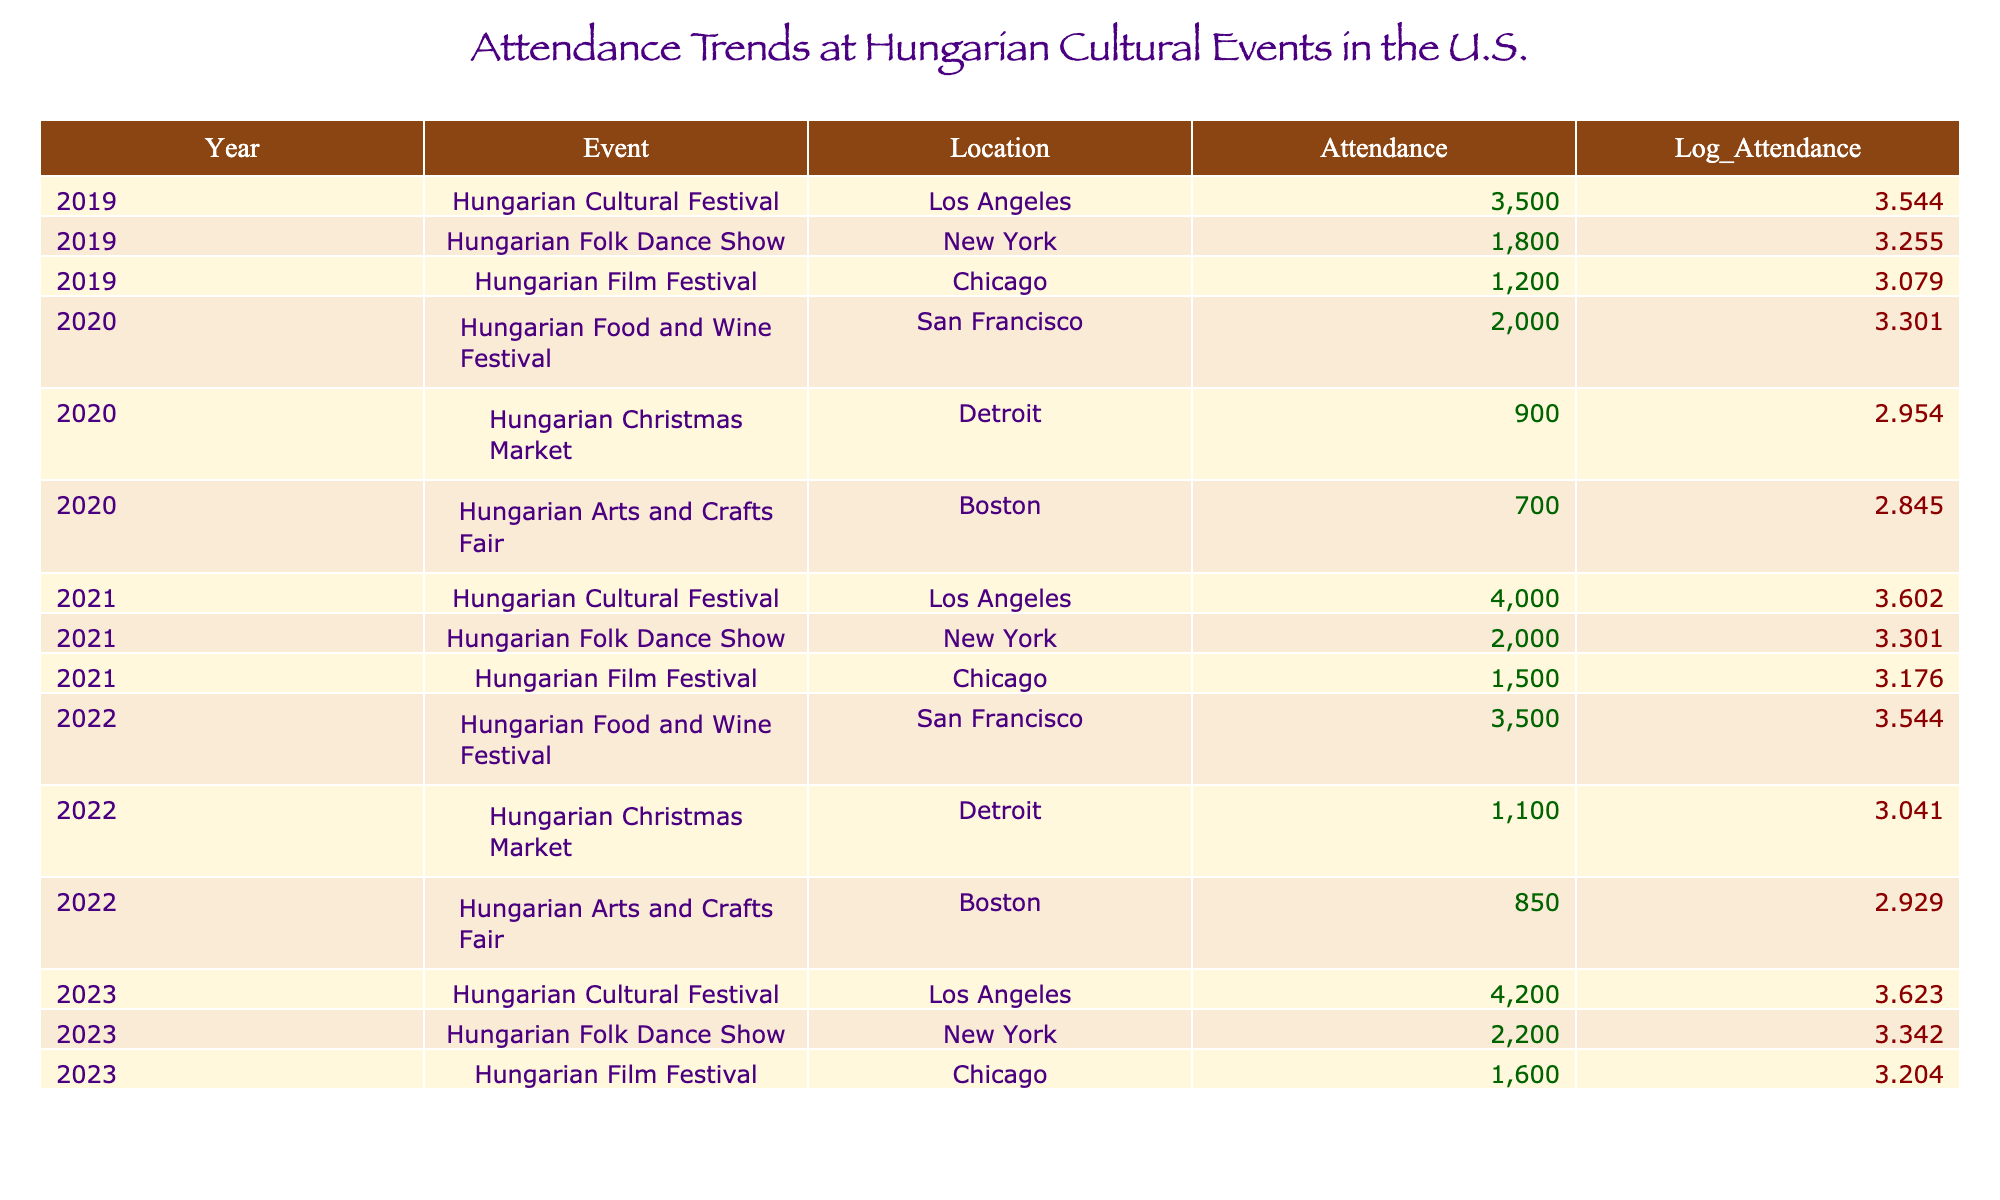What was the attendance at the Hungarian Folk Dance Show in 2021? The table shows that the attendance at the Hungarian Folk Dance Show in 2021 was 2000.
Answer: 2000 Which event had the highest attendance in 2023? According to the table, the Hungarian Cultural Festival in Los Angeles had the highest attendance in 2023, with 4200 participants.
Answer: 4200 What is the total attendance across all events in 2020? The attendance for each event in 2020 is 2000 (Food and Wine Festival) + 900 (Christmas Market) + 700 (Arts and Crafts Fair) = 3600.
Answer: 3600 Did attendance at the Hungarian Film Festival increase from 2019 to 2023? In 2019, the attendance was 1200 and in 2023 it was 1600. Since 1600 is greater than 1200, it indicates an increase.
Answer: Yes What was the trend in attendance from 2019 to 2023 for the Hungarian Cultural Festival? The attendance figures for the Hungarian Cultural Festival are: 3500 in 2019, 4000 in 2021, and 4200 in 2023. This shows a steady increase in attendance over these years.
Answer: Increasing What was the average attendance for the Hungarian Arts and Crafts Fair over the five years? The attendance figures for the Hungarian Arts and Crafts Fair are: 700 (2020), 850 (2022), and no data for 2019, 2021, and 2023. Thus, the average is (700 + 850) / 2 = 775.
Answer: 775 Was 2022 the year with the lowest attendance for the Hungarian Christmas Market? The attendance for the Hungarian Christmas Market in 2022 was 1100, compared to 900 in 2020. Since 900 is lower, 2022 was not the lowest year.
Answer: No Which event maintained consistent attendance (or nearly the same) over the five years? Looking at the table, the attendance for the Hungarian Folk Dance Show varies between years (1800 in 2019, 2000 in 2021, and 2200 in 2023), showing an upward trend, but not consistent. No event shows consistent attendance in terms of exact numbers across years.
Answer: None 